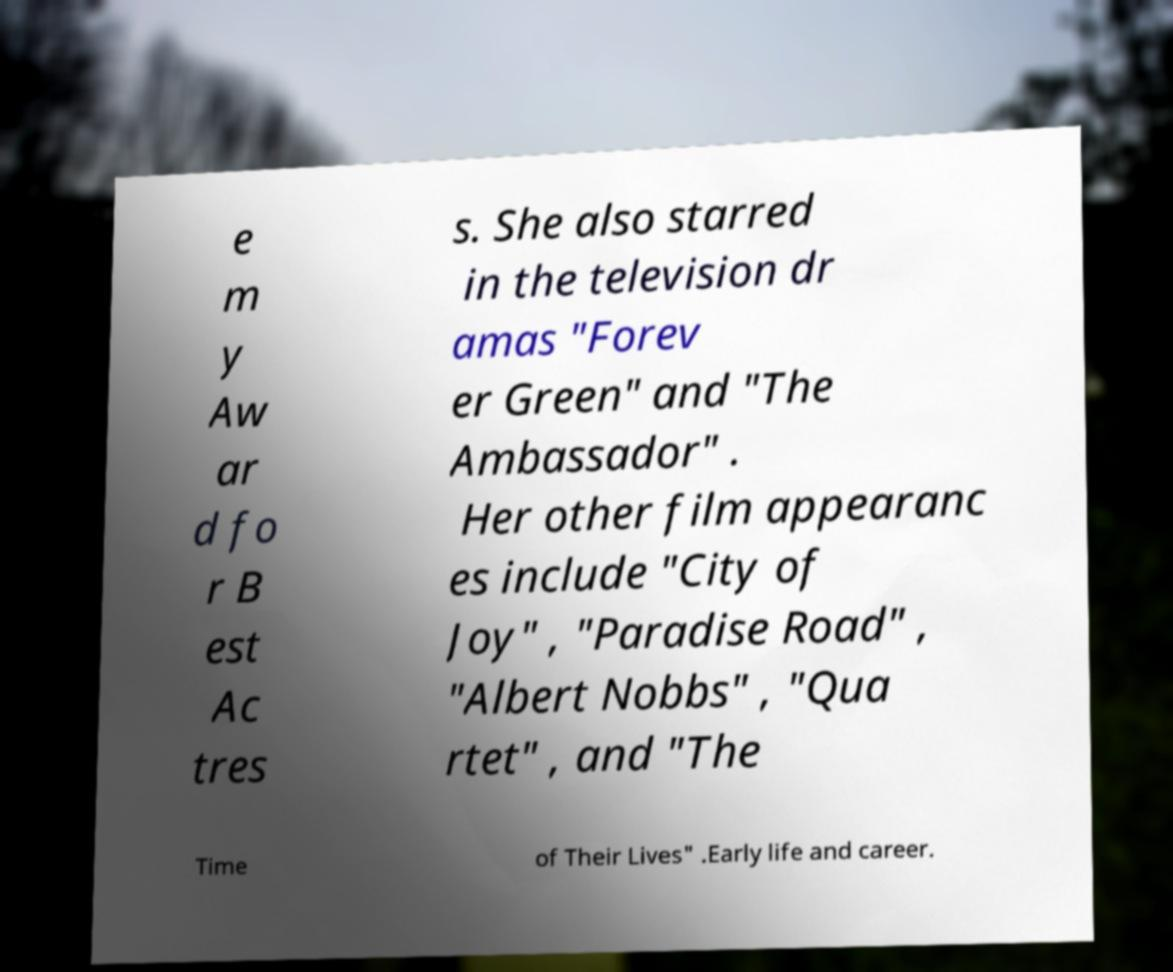For documentation purposes, I need the text within this image transcribed. Could you provide that? e m y Aw ar d fo r B est Ac tres s. She also starred in the television dr amas "Forev er Green" and "The Ambassador" . Her other film appearanc es include "City of Joy" , "Paradise Road" , "Albert Nobbs" , "Qua rtet" , and "The Time of Their Lives" .Early life and career. 